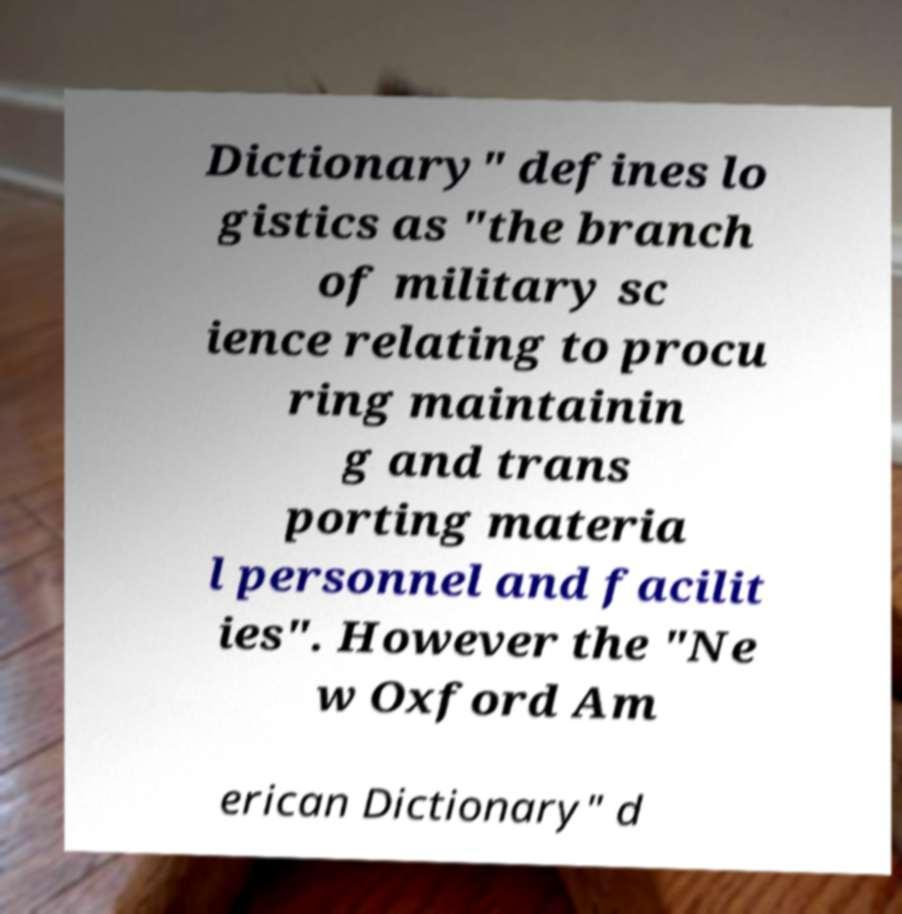Can you read and provide the text displayed in the image?This photo seems to have some interesting text. Can you extract and type it out for me? Dictionary" defines lo gistics as "the branch of military sc ience relating to procu ring maintainin g and trans porting materia l personnel and facilit ies". However the "Ne w Oxford Am erican Dictionary" d 